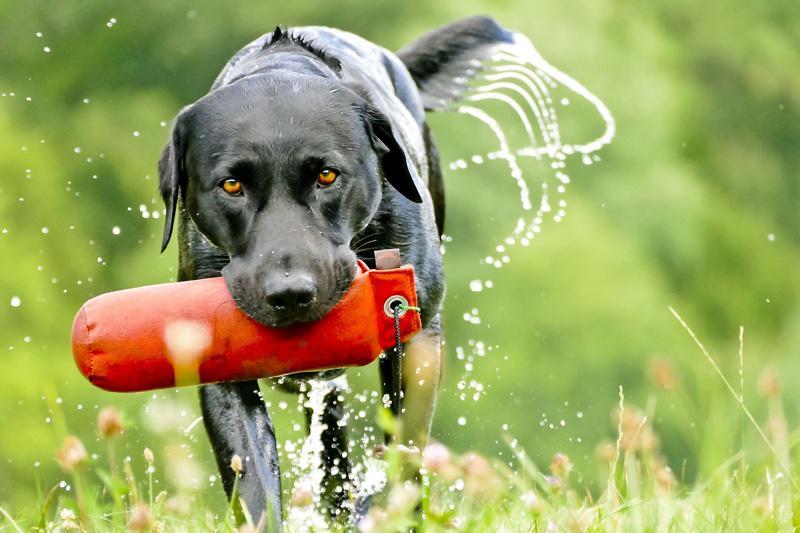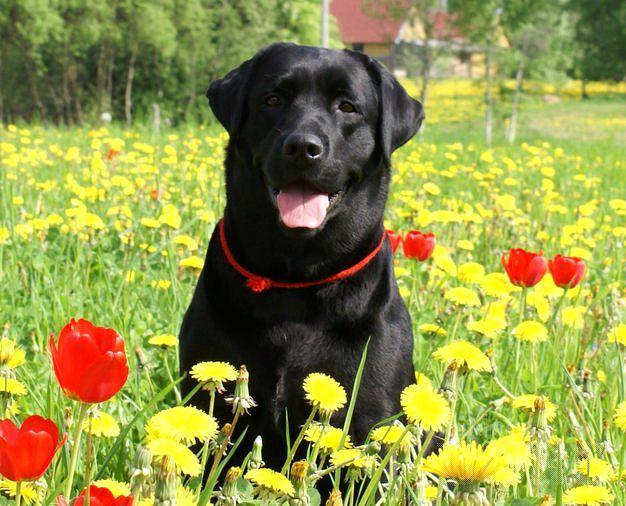The first image is the image on the left, the second image is the image on the right. Analyze the images presented: Is the assertion "In at least one image, a dog is in a body of water while wearing a life jacket or flotation device of some kind" valid? Answer yes or no. No. The first image is the image on the left, the second image is the image on the right. Considering the images on both sides, is "The left image contains one dog that is black." valid? Answer yes or no. Yes. 